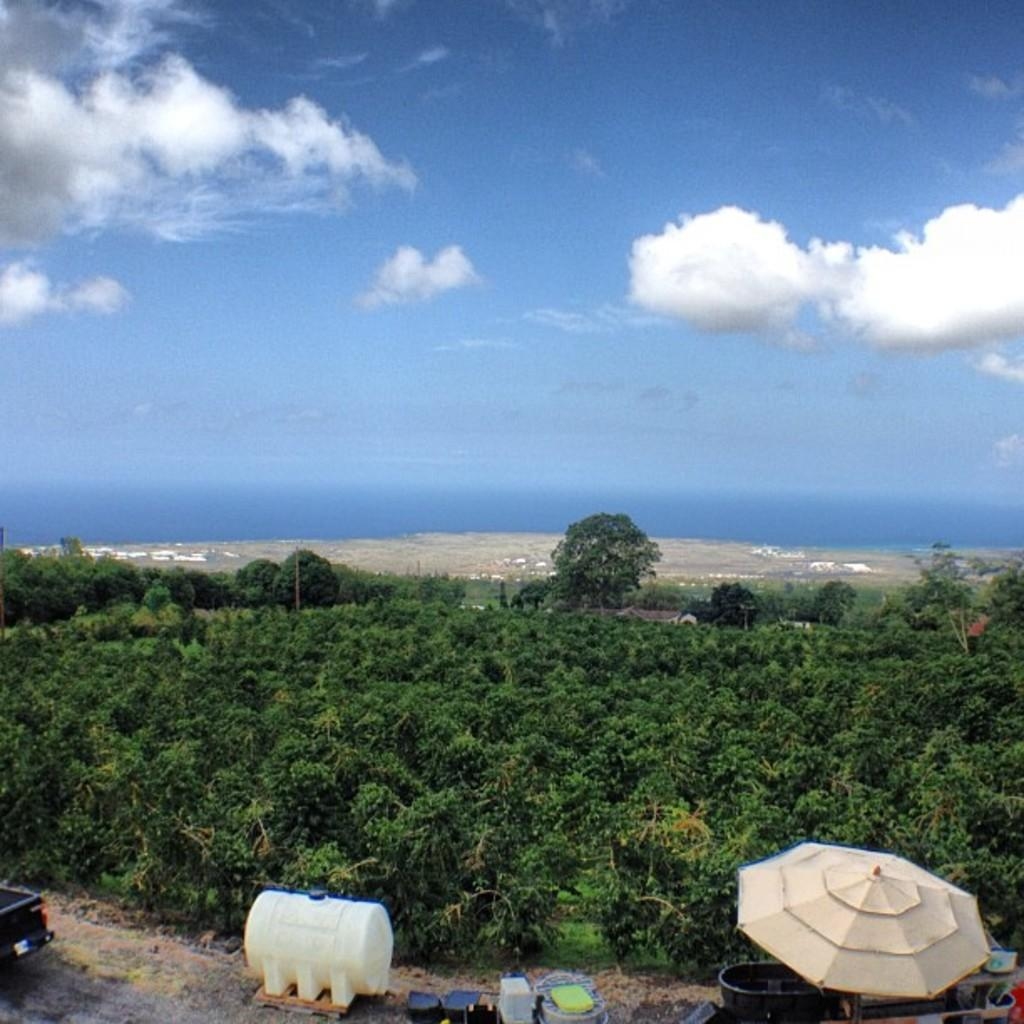What is located at the bottom of the image? There are objects placed on the path at the bottom of the image. What can be seen in the middle of the image? There are trees and plants in the middle of the image. What is visible in the background of the image? The sky is visible in the background of the image. Can you describe the sky in the image? The sky in the image has clouds visible in the background. What type of hen can be seen walking along the path in the image? There is no hen present in the image; it only features objects placed on the path. What channel is the image broadcasted on? The image is not a video or broadcasted on any channel; it is a static image. 